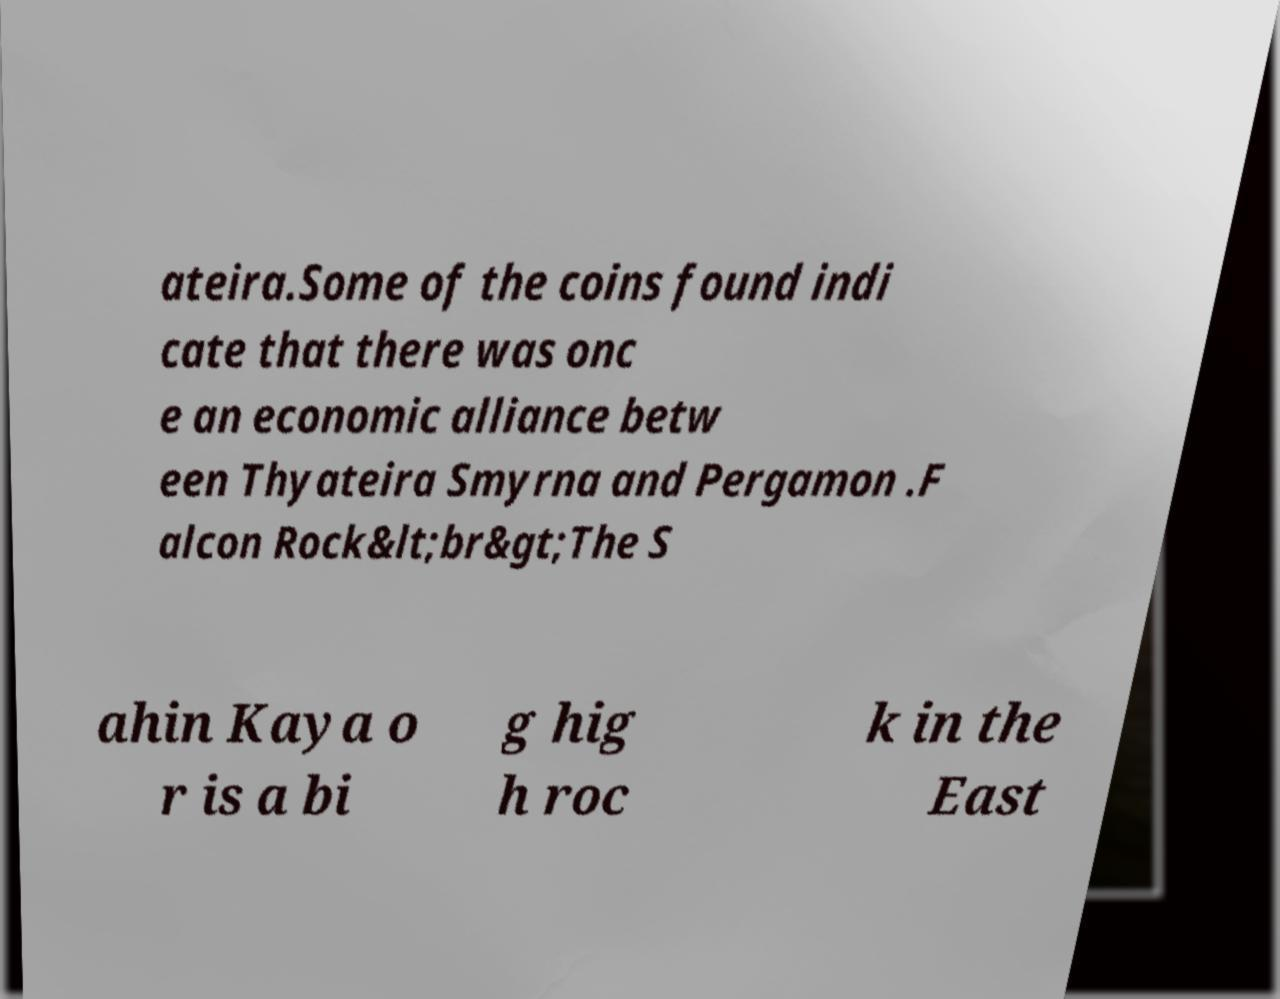What messages or text are displayed in this image? I need them in a readable, typed format. ateira.Some of the coins found indi cate that there was onc e an economic alliance betw een Thyateira Smyrna and Pergamon .F alcon Rock&lt;br&gt;The S ahin Kaya o r is a bi g hig h roc k in the East 